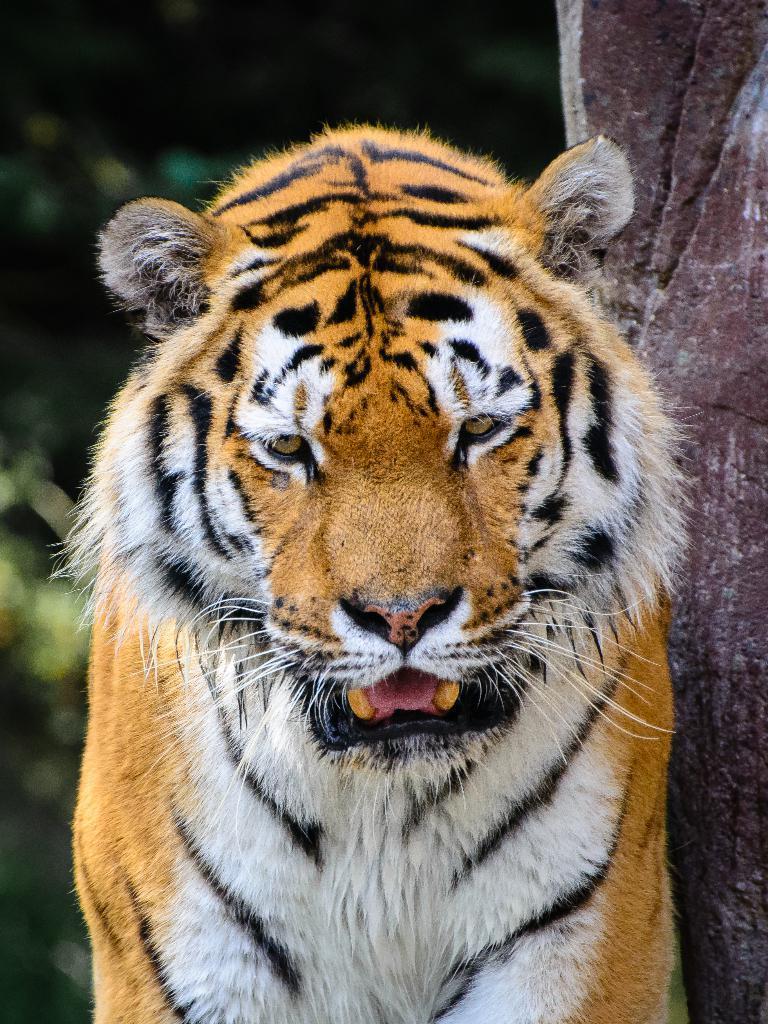Please provide a concise description of this image. In this image we can see a tiger. In the background the image is blur but we can see objects and on the right side we can see an object. 